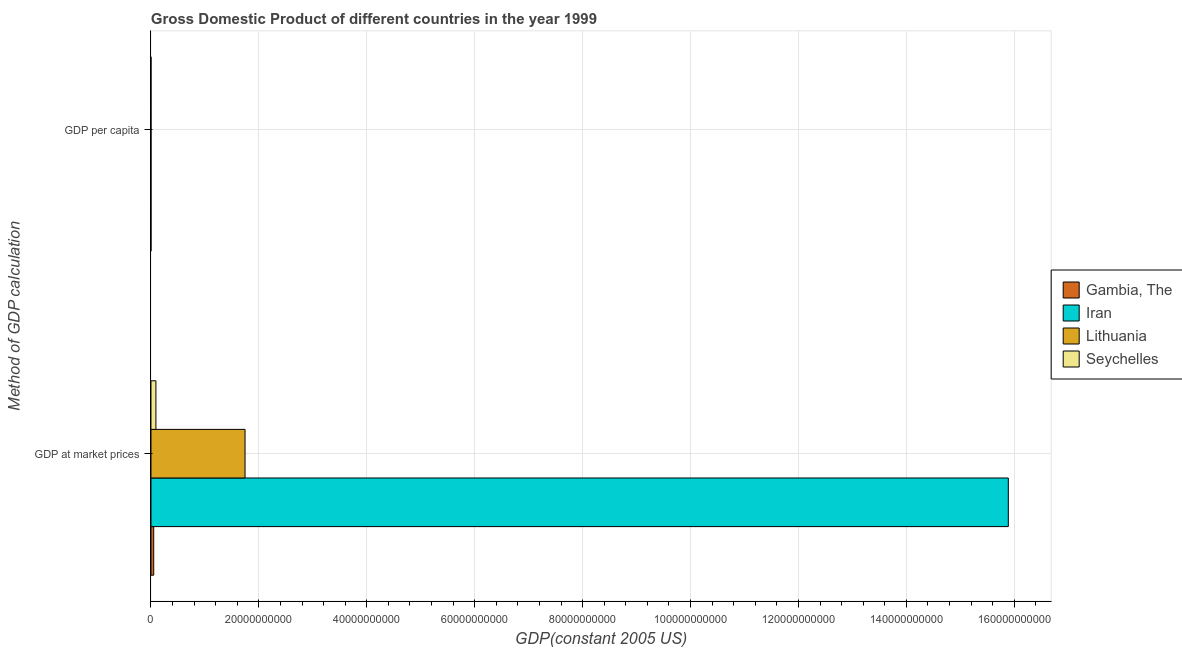How many groups of bars are there?
Your answer should be very brief. 2. Are the number of bars on each tick of the Y-axis equal?
Give a very brief answer. Yes. How many bars are there on the 2nd tick from the top?
Ensure brevity in your answer.  4. How many bars are there on the 2nd tick from the bottom?
Keep it short and to the point. 4. What is the label of the 2nd group of bars from the top?
Provide a succinct answer. GDP at market prices. What is the gdp per capita in Iran?
Offer a terse response. 2452.83. Across all countries, what is the maximum gdp at market prices?
Provide a succinct answer. 1.59e+11. Across all countries, what is the minimum gdp per capita?
Provide a succinct answer. 427.54. In which country was the gdp per capita maximum?
Keep it short and to the point. Seychelles. In which country was the gdp per capita minimum?
Give a very brief answer. Gambia, The. What is the total gdp at market prices in the graph?
Offer a terse response. 1.78e+11. What is the difference between the gdp per capita in Gambia, The and that in Seychelles?
Offer a terse response. -1.10e+04. What is the difference between the gdp per capita in Gambia, The and the gdp at market prices in Iran?
Keep it short and to the point. -1.59e+11. What is the average gdp at market prices per country?
Ensure brevity in your answer.  4.44e+1. What is the difference between the gdp at market prices and gdp per capita in Lithuania?
Give a very brief answer. 1.74e+1. What is the ratio of the gdp per capita in Seychelles to that in Iran?
Make the answer very short. 4.66. Is the gdp at market prices in Iran less than that in Seychelles?
Your answer should be very brief. No. What does the 2nd bar from the top in GDP at market prices represents?
Your answer should be compact. Lithuania. What does the 2nd bar from the bottom in GDP per capita represents?
Your answer should be compact. Iran. Are all the bars in the graph horizontal?
Offer a very short reply. Yes. How many countries are there in the graph?
Offer a very short reply. 4. Does the graph contain any zero values?
Make the answer very short. No. Where does the legend appear in the graph?
Offer a very short reply. Center right. How are the legend labels stacked?
Give a very brief answer. Vertical. What is the title of the graph?
Your response must be concise. Gross Domestic Product of different countries in the year 1999. What is the label or title of the X-axis?
Your answer should be very brief. GDP(constant 2005 US). What is the label or title of the Y-axis?
Make the answer very short. Method of GDP calculation. What is the GDP(constant 2005 US) of Gambia, The in GDP at market prices?
Ensure brevity in your answer.  5.10e+08. What is the GDP(constant 2005 US) in Iran in GDP at market prices?
Offer a very short reply. 1.59e+11. What is the GDP(constant 2005 US) of Lithuania in GDP at market prices?
Provide a short and direct response. 1.74e+1. What is the GDP(constant 2005 US) of Seychelles in GDP at market prices?
Offer a very short reply. 9.18e+08. What is the GDP(constant 2005 US) of Gambia, The in GDP per capita?
Your answer should be compact. 427.54. What is the GDP(constant 2005 US) in Iran in GDP per capita?
Offer a terse response. 2452.83. What is the GDP(constant 2005 US) of Lithuania in GDP per capita?
Give a very brief answer. 4947.85. What is the GDP(constant 2005 US) in Seychelles in GDP per capita?
Offer a terse response. 1.14e+04. Across all Method of GDP calculation, what is the maximum GDP(constant 2005 US) in Gambia, The?
Give a very brief answer. 5.10e+08. Across all Method of GDP calculation, what is the maximum GDP(constant 2005 US) in Iran?
Ensure brevity in your answer.  1.59e+11. Across all Method of GDP calculation, what is the maximum GDP(constant 2005 US) of Lithuania?
Offer a terse response. 1.74e+1. Across all Method of GDP calculation, what is the maximum GDP(constant 2005 US) of Seychelles?
Your response must be concise. 9.18e+08. Across all Method of GDP calculation, what is the minimum GDP(constant 2005 US) of Gambia, The?
Offer a very short reply. 427.54. Across all Method of GDP calculation, what is the minimum GDP(constant 2005 US) of Iran?
Offer a terse response. 2452.83. Across all Method of GDP calculation, what is the minimum GDP(constant 2005 US) of Lithuania?
Your response must be concise. 4947.85. Across all Method of GDP calculation, what is the minimum GDP(constant 2005 US) in Seychelles?
Provide a succinct answer. 1.14e+04. What is the total GDP(constant 2005 US) in Gambia, The in the graph?
Provide a succinct answer. 5.10e+08. What is the total GDP(constant 2005 US) in Iran in the graph?
Keep it short and to the point. 1.59e+11. What is the total GDP(constant 2005 US) of Lithuania in the graph?
Provide a short and direct response. 1.74e+1. What is the total GDP(constant 2005 US) of Seychelles in the graph?
Ensure brevity in your answer.  9.18e+08. What is the difference between the GDP(constant 2005 US) in Gambia, The in GDP at market prices and that in GDP per capita?
Provide a short and direct response. 5.10e+08. What is the difference between the GDP(constant 2005 US) of Iran in GDP at market prices and that in GDP per capita?
Your response must be concise. 1.59e+11. What is the difference between the GDP(constant 2005 US) of Lithuania in GDP at market prices and that in GDP per capita?
Provide a short and direct response. 1.74e+1. What is the difference between the GDP(constant 2005 US) of Seychelles in GDP at market prices and that in GDP per capita?
Provide a succinct answer. 9.18e+08. What is the difference between the GDP(constant 2005 US) in Gambia, The in GDP at market prices and the GDP(constant 2005 US) in Iran in GDP per capita?
Provide a succinct answer. 5.10e+08. What is the difference between the GDP(constant 2005 US) in Gambia, The in GDP at market prices and the GDP(constant 2005 US) in Lithuania in GDP per capita?
Offer a terse response. 5.10e+08. What is the difference between the GDP(constant 2005 US) of Gambia, The in GDP at market prices and the GDP(constant 2005 US) of Seychelles in GDP per capita?
Keep it short and to the point. 5.10e+08. What is the difference between the GDP(constant 2005 US) in Iran in GDP at market prices and the GDP(constant 2005 US) in Lithuania in GDP per capita?
Offer a terse response. 1.59e+11. What is the difference between the GDP(constant 2005 US) in Iran in GDP at market prices and the GDP(constant 2005 US) in Seychelles in GDP per capita?
Your answer should be compact. 1.59e+11. What is the difference between the GDP(constant 2005 US) in Lithuania in GDP at market prices and the GDP(constant 2005 US) in Seychelles in GDP per capita?
Your response must be concise. 1.74e+1. What is the average GDP(constant 2005 US) of Gambia, The per Method of GDP calculation?
Your response must be concise. 2.55e+08. What is the average GDP(constant 2005 US) of Iran per Method of GDP calculation?
Provide a short and direct response. 7.94e+1. What is the average GDP(constant 2005 US) in Lithuania per Method of GDP calculation?
Your response must be concise. 8.72e+09. What is the average GDP(constant 2005 US) of Seychelles per Method of GDP calculation?
Provide a short and direct response. 4.59e+08. What is the difference between the GDP(constant 2005 US) of Gambia, The and GDP(constant 2005 US) of Iran in GDP at market prices?
Ensure brevity in your answer.  -1.58e+11. What is the difference between the GDP(constant 2005 US) of Gambia, The and GDP(constant 2005 US) of Lithuania in GDP at market prices?
Offer a very short reply. -1.69e+1. What is the difference between the GDP(constant 2005 US) in Gambia, The and GDP(constant 2005 US) in Seychelles in GDP at market prices?
Provide a succinct answer. -4.08e+08. What is the difference between the GDP(constant 2005 US) of Iran and GDP(constant 2005 US) of Lithuania in GDP at market prices?
Your answer should be very brief. 1.41e+11. What is the difference between the GDP(constant 2005 US) in Iran and GDP(constant 2005 US) in Seychelles in GDP at market prices?
Make the answer very short. 1.58e+11. What is the difference between the GDP(constant 2005 US) in Lithuania and GDP(constant 2005 US) in Seychelles in GDP at market prices?
Keep it short and to the point. 1.65e+1. What is the difference between the GDP(constant 2005 US) of Gambia, The and GDP(constant 2005 US) of Iran in GDP per capita?
Keep it short and to the point. -2025.29. What is the difference between the GDP(constant 2005 US) in Gambia, The and GDP(constant 2005 US) in Lithuania in GDP per capita?
Keep it short and to the point. -4520.31. What is the difference between the GDP(constant 2005 US) of Gambia, The and GDP(constant 2005 US) of Seychelles in GDP per capita?
Your answer should be very brief. -1.10e+04. What is the difference between the GDP(constant 2005 US) in Iran and GDP(constant 2005 US) in Lithuania in GDP per capita?
Ensure brevity in your answer.  -2495.02. What is the difference between the GDP(constant 2005 US) of Iran and GDP(constant 2005 US) of Seychelles in GDP per capita?
Provide a short and direct response. -8968.83. What is the difference between the GDP(constant 2005 US) of Lithuania and GDP(constant 2005 US) of Seychelles in GDP per capita?
Offer a very short reply. -6473.82. What is the ratio of the GDP(constant 2005 US) in Gambia, The in GDP at market prices to that in GDP per capita?
Your answer should be compact. 1.19e+06. What is the ratio of the GDP(constant 2005 US) in Iran in GDP at market prices to that in GDP per capita?
Offer a terse response. 6.48e+07. What is the ratio of the GDP(constant 2005 US) of Lithuania in GDP at market prices to that in GDP per capita?
Your answer should be compact. 3.52e+06. What is the ratio of the GDP(constant 2005 US) in Seychelles in GDP at market prices to that in GDP per capita?
Keep it short and to the point. 8.04e+04. What is the difference between the highest and the second highest GDP(constant 2005 US) in Gambia, The?
Ensure brevity in your answer.  5.10e+08. What is the difference between the highest and the second highest GDP(constant 2005 US) of Iran?
Provide a succinct answer. 1.59e+11. What is the difference between the highest and the second highest GDP(constant 2005 US) of Lithuania?
Offer a very short reply. 1.74e+1. What is the difference between the highest and the second highest GDP(constant 2005 US) in Seychelles?
Offer a very short reply. 9.18e+08. What is the difference between the highest and the lowest GDP(constant 2005 US) of Gambia, The?
Provide a short and direct response. 5.10e+08. What is the difference between the highest and the lowest GDP(constant 2005 US) of Iran?
Your answer should be very brief. 1.59e+11. What is the difference between the highest and the lowest GDP(constant 2005 US) in Lithuania?
Offer a very short reply. 1.74e+1. What is the difference between the highest and the lowest GDP(constant 2005 US) in Seychelles?
Offer a terse response. 9.18e+08. 